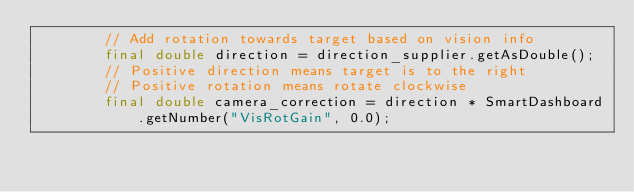Convert code to text. <code><loc_0><loc_0><loc_500><loc_500><_Java_>        // Add rotation towards target based on vision info
        final double direction = direction_supplier.getAsDouble();
        // Positive direction means target is to the right
        // Positive rotation means rotate clockwise
        final double camera_correction = direction * SmartDashboard.getNumber("VisRotGain", 0.0);</code> 